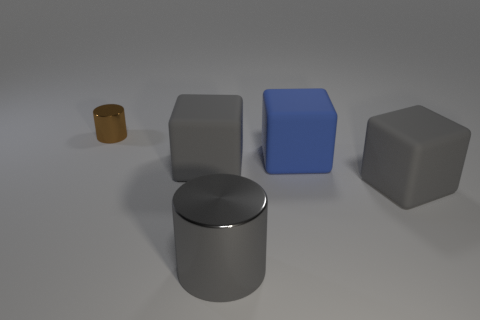Subtract all blue rubber blocks. How many blocks are left? 2 Add 3 large green matte cylinders. How many objects exist? 8 Subtract all blue blocks. How many blocks are left? 2 Subtract 0 red cylinders. How many objects are left? 5 Subtract all blocks. How many objects are left? 2 Subtract 1 cubes. How many cubes are left? 2 Subtract all yellow cylinders. Subtract all cyan spheres. How many cylinders are left? 2 Subtract all gray blocks. How many brown cylinders are left? 1 Subtract all metallic cubes. Subtract all blue rubber blocks. How many objects are left? 4 Add 2 tiny brown objects. How many tiny brown objects are left? 3 